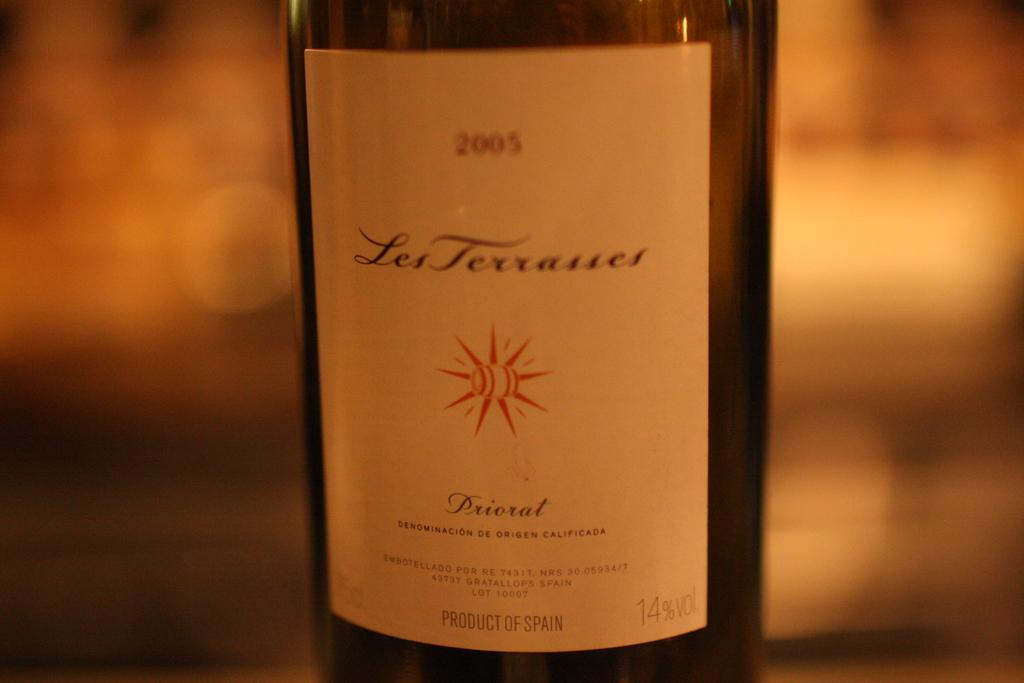What year is this wine?
Offer a very short reply. 2005. 